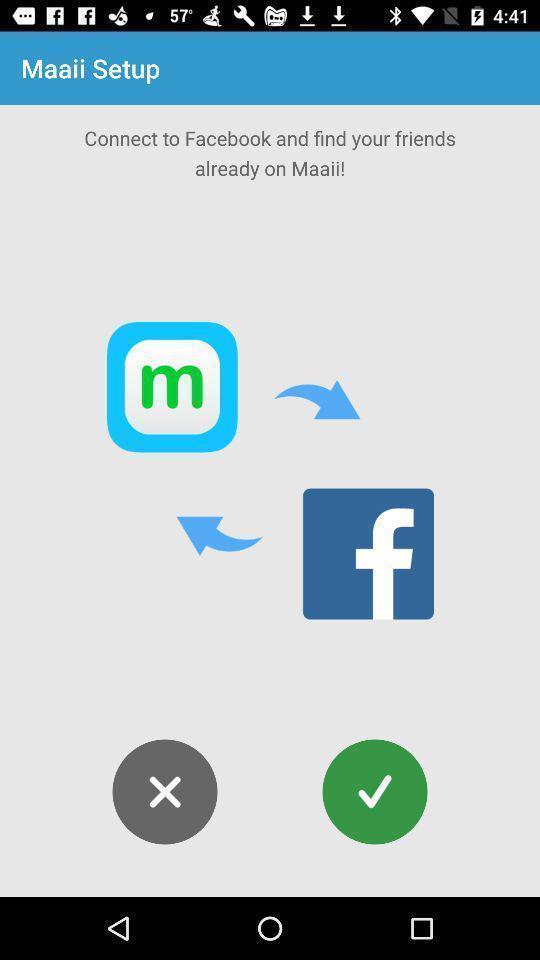Provide a detailed account of this screenshot. Set up page of connecting application. 